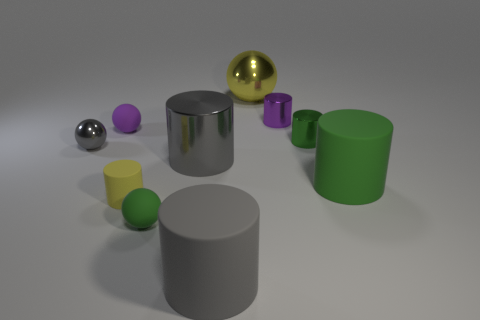Subtract 1 spheres. How many spheres are left? 3 Subtract all gray cylinders. How many cylinders are left? 4 Subtract all big green cylinders. How many cylinders are left? 5 Subtract all purple cylinders. Subtract all yellow spheres. How many cylinders are left? 5 Subtract all cylinders. How many objects are left? 4 Subtract 0 blue spheres. How many objects are left? 10 Subtract all purple cylinders. Subtract all purple cylinders. How many objects are left? 8 Add 9 tiny matte cylinders. How many tiny matte cylinders are left? 10 Add 9 big yellow shiny things. How many big yellow shiny things exist? 10 